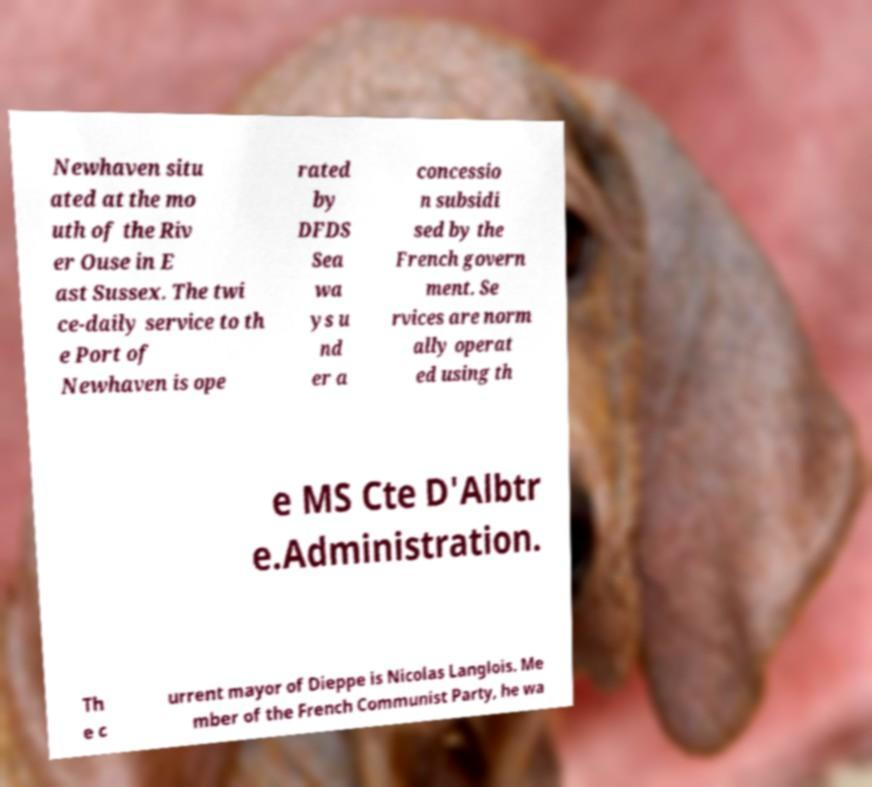What messages or text are displayed in this image? I need them in a readable, typed format. Newhaven situ ated at the mo uth of the Riv er Ouse in E ast Sussex. The twi ce-daily service to th e Port of Newhaven is ope rated by DFDS Sea wa ys u nd er a concessio n subsidi sed by the French govern ment. Se rvices are norm ally operat ed using th e MS Cte D'Albtr e.Administration. Th e c urrent mayor of Dieppe is Nicolas Langlois. Me mber of the French Communist Party, he wa 